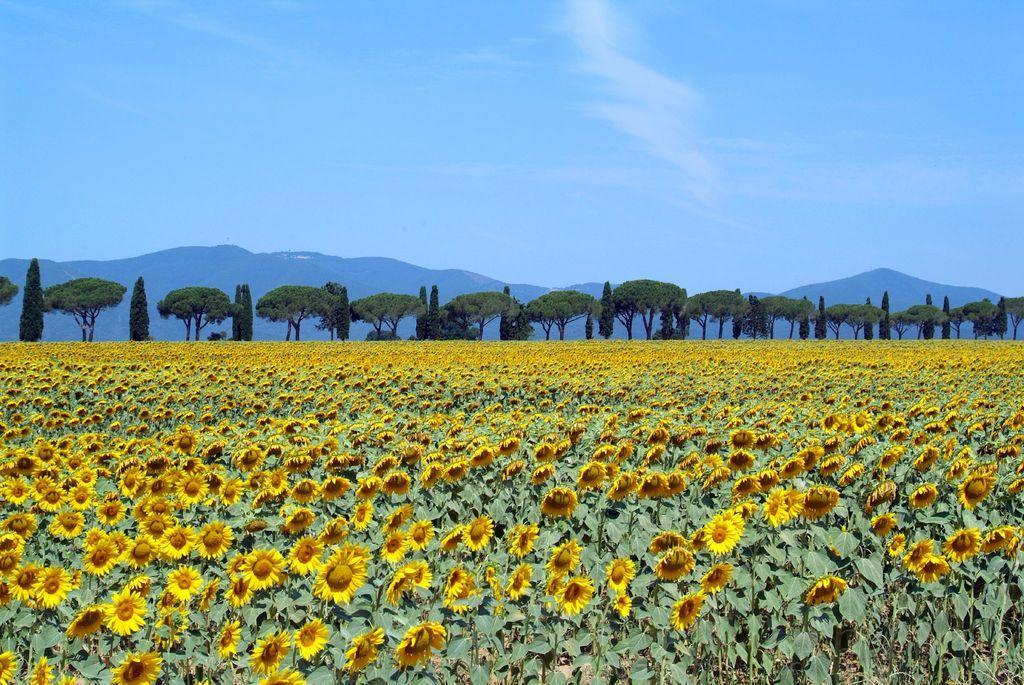Describe this image in one or two sentences. In this image I can see the yellow color flowers to the plant. In the background there are many trees and mountains. I can also see the sky in the back. 